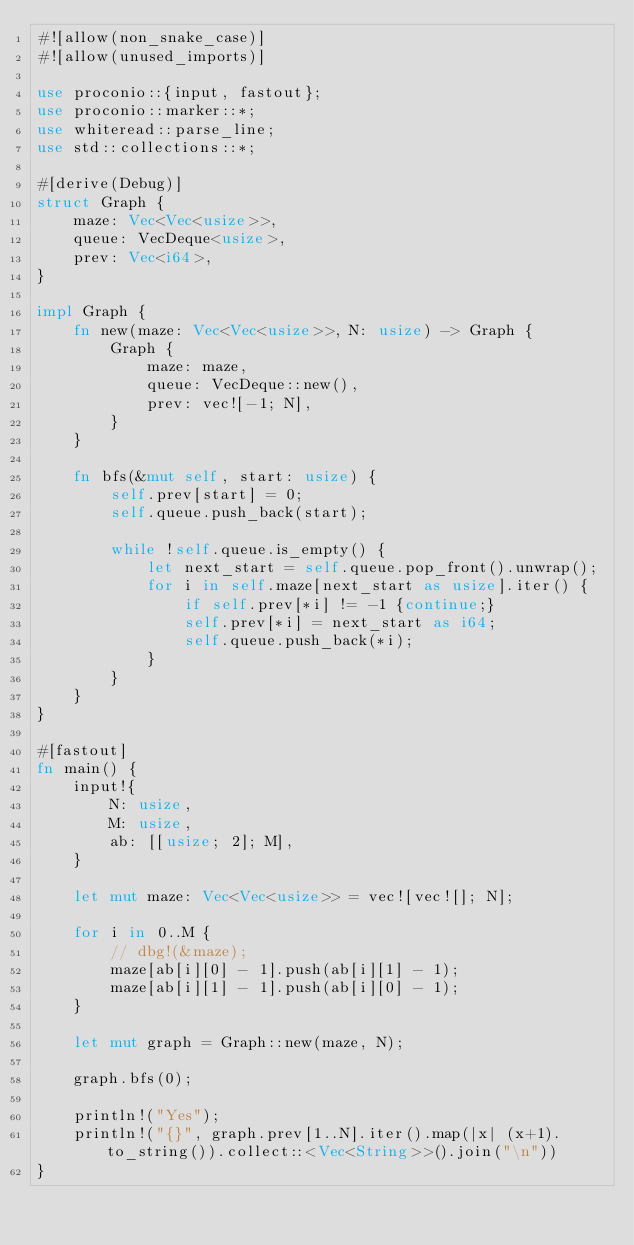<code> <loc_0><loc_0><loc_500><loc_500><_Rust_>#![allow(non_snake_case)]
#![allow(unused_imports)]
 
use proconio::{input, fastout};
use proconio::marker::*;
use whiteread::parse_line;
use std::collections::*;

#[derive(Debug)]
struct Graph {
    maze: Vec<Vec<usize>>,
    queue: VecDeque<usize>,
    prev: Vec<i64>,
}

impl Graph {
    fn new(maze: Vec<Vec<usize>>, N: usize) -> Graph {
        Graph {
            maze: maze,
            queue: VecDeque::new(),
            prev: vec![-1; N],
        }
    }

    fn bfs(&mut self, start: usize) {
        self.prev[start] = 0;
        self.queue.push_back(start);

        while !self.queue.is_empty() {
            let next_start = self.queue.pop_front().unwrap();
            for i in self.maze[next_start as usize].iter() {
                if self.prev[*i] != -1 {continue;}
                self.prev[*i] = next_start as i64;
                self.queue.push_back(*i);
            }
        }
    }
}

#[fastout]
fn main() {
    input!{
        N: usize,
        M: usize,
        ab: [[usize; 2]; M],
    }

    let mut maze: Vec<Vec<usize>> = vec![vec![]; N];

    for i in 0..M {
        // dbg!(&maze);
        maze[ab[i][0] - 1].push(ab[i][1] - 1);
        maze[ab[i][1] - 1].push(ab[i][0] - 1);
    }

    let mut graph = Graph::new(maze, N);
    
    graph.bfs(0);

    println!("Yes");
    println!("{}", graph.prev[1..N].iter().map(|x| (x+1).to_string()).collect::<Vec<String>>().join("\n"))
}
</code> 